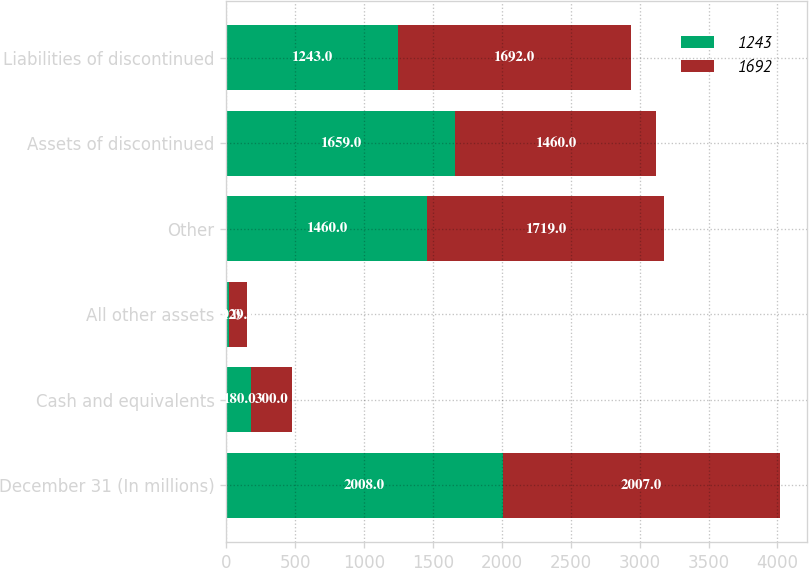Convert chart. <chart><loc_0><loc_0><loc_500><loc_500><stacked_bar_chart><ecel><fcel>December 31 (In millions)<fcel>Cash and equivalents<fcel>All other assets<fcel>Other<fcel>Assets of discontinued<fcel>Liabilities of discontinued<nl><fcel>1243<fcel>2008<fcel>180<fcel>19<fcel>1460<fcel>1659<fcel>1243<nl><fcel>1692<fcel>2007<fcel>300<fcel>129<fcel>1719<fcel>1460<fcel>1692<nl></chart> 